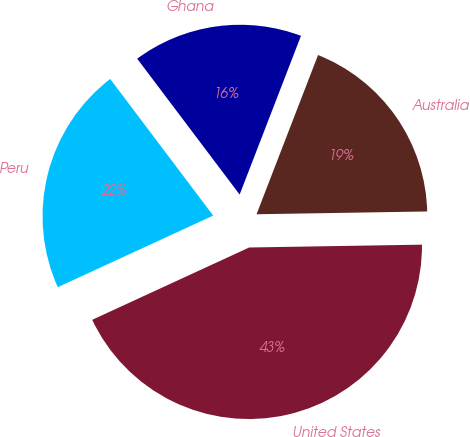<chart> <loc_0><loc_0><loc_500><loc_500><pie_chart><fcel>United States<fcel>Australia<fcel>Ghana<fcel>Peru<nl><fcel>43.39%<fcel>18.87%<fcel>16.15%<fcel>21.59%<nl></chart> 